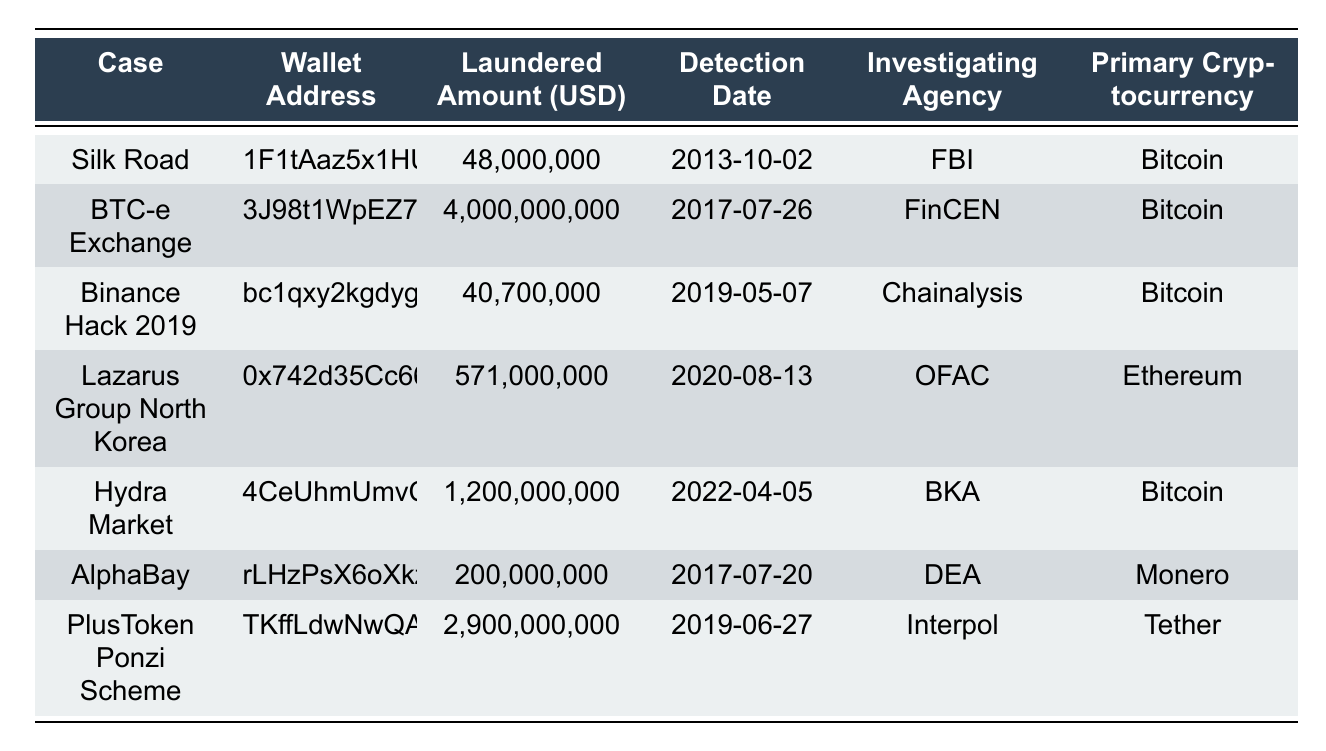What is the total amount laundered across all cases? To find the total laundered amount, sum all the values in the "Laundered Amount (USD)" column: 48,000,000 + 4,000,000,000 + 40,700,000 + 571,000,000 + 1,200,000,000 + 200,000,000 + 2,900,000,000 = 8,960,700,000
Answer: 8,960,700,000 Which case had the highest laundered amount? The highest laundered amount is found in the "Laundered Amount (USD)" column. Comparing the amounts, 4,000,000,000 for the "BTC-e Exchange" case is the maximum value.
Answer: BTC-e Exchange How many different investigating agencies are involved in these cases? The investigating agencies are listed in the "Investigating Agency" column. Counting the unique agencies: FBI, FinCEN, Chainalysis, OFAC, BKA, DEA, and Interpol gives a total of 7 different agencies.
Answer: 7 What is the primary cryptocurrency associated with the "Hydra Market" case? The "Hydra Market" case corresponds to the row in the table, which lists "Bitcoin" under the "Primary Cryptocurrency" column.
Answer: Bitcoin Which case had the detection date earliest among all? By inspecting the "Detection Date" column, the earliest date is 2013-10-02, which corresponds to the "Silk Road" case.
Answer: Silk Road What is the average laundered amount for the cryptocurrency "Bitcoin"? The total laundered amount for Bitcoin is calculated by summing the amounts for the "Silk Road", "BTC-e Exchange", "Binance Hack 2019", "Hydra Market": 48,000,000 + 4,000,000,000 + 40,700,000 + 1,200,000,000 = 5,288,700,000. There are 4 cases of Bitcoin so the average is 5,288,700,000 / 4 = 1,322,175,000.
Answer: 1,322,175,000 Is there any case where Tether was the primary cryptocurrency? By checking the "Primary Cryptocurrency" column, "Tether" is associated with the "PlusToken Ponzi Scheme", indicating that there is indeed such a case.
Answer: Yes What is the laundered amount for the "Lazarus Group North Korea" case? The amount laundered for this case is listed directly in the "Laundered Amount (USD)" column, which shows 571,000,000.
Answer: 571,000,000 Which agency investigated the "AlphaBay" case? The agency responsible for the "AlphaBay" case is specified in the "Investigating Agency" column, which lists "DEA".
Answer: DEA What is the difference in laundered amounts between the highest and lowest cases? The highest amount is for "BTC-e Exchange" at 4,000,000,000 and the lowest is for "Silk Road" at 48,000,000. The difference is 4,000,000,000 - 48,000,000 = 3,952,000,000.
Answer: 3,952,000,000 How many cases were detected after the year 2020? By checking the "Detection Date" column, the cases detected after 2020 are "Hydra Market" (2022-04-05), and "PlusToken Ponzi Scheme" (2019-06-27), totaling 2 cases.
Answer: 2 